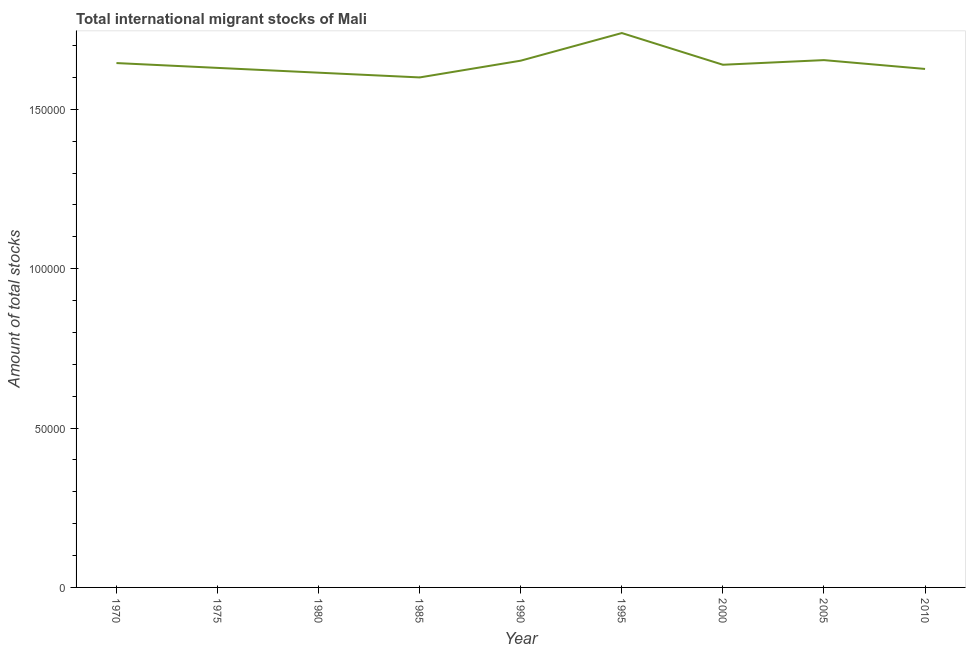What is the total number of international migrant stock in 1990?
Your answer should be very brief. 1.65e+05. Across all years, what is the maximum total number of international migrant stock?
Offer a very short reply. 1.74e+05. Across all years, what is the minimum total number of international migrant stock?
Your answer should be compact. 1.60e+05. In which year was the total number of international migrant stock minimum?
Give a very brief answer. 1985. What is the sum of the total number of international migrant stock?
Provide a succinct answer. 1.48e+06. What is the difference between the total number of international migrant stock in 1970 and 2005?
Make the answer very short. -925. What is the average total number of international migrant stock per year?
Your answer should be compact. 1.64e+05. What is the median total number of international migrant stock?
Your response must be concise. 1.64e+05. Do a majority of the years between 1995 and 1980 (inclusive) have total number of international migrant stock greater than 80000 ?
Provide a short and direct response. Yes. What is the ratio of the total number of international migrant stock in 1985 to that in 2000?
Make the answer very short. 0.98. Is the total number of international migrant stock in 1990 less than that in 2010?
Your response must be concise. No. Is the difference between the total number of international migrant stock in 1970 and 2005 greater than the difference between any two years?
Give a very brief answer. No. What is the difference between the highest and the second highest total number of international migrant stock?
Offer a terse response. 8494. Is the sum of the total number of international migrant stock in 1975 and 2000 greater than the maximum total number of international migrant stock across all years?
Ensure brevity in your answer.  Yes. What is the difference between the highest and the lowest total number of international migrant stock?
Your response must be concise. 1.39e+04. In how many years, is the total number of international migrant stock greater than the average total number of international migrant stock taken over all years?
Your response must be concise. 4. Does the total number of international migrant stock monotonically increase over the years?
Provide a succinct answer. No. How many years are there in the graph?
Give a very brief answer. 9. What is the difference between two consecutive major ticks on the Y-axis?
Keep it short and to the point. 5.00e+04. What is the title of the graph?
Your answer should be very brief. Total international migrant stocks of Mali. What is the label or title of the Y-axis?
Provide a short and direct response. Amount of total stocks. What is the Amount of total stocks in 1970?
Offer a very short reply. 1.65e+05. What is the Amount of total stocks of 1975?
Your response must be concise. 1.63e+05. What is the Amount of total stocks in 1980?
Keep it short and to the point. 1.62e+05. What is the Amount of total stocks in 1985?
Provide a succinct answer. 1.60e+05. What is the Amount of total stocks of 1990?
Your answer should be very brief. 1.65e+05. What is the Amount of total stocks of 1995?
Provide a short and direct response. 1.74e+05. What is the Amount of total stocks in 2000?
Your response must be concise. 1.64e+05. What is the Amount of total stocks in 2005?
Make the answer very short. 1.65e+05. What is the Amount of total stocks of 2010?
Provide a short and direct response. 1.63e+05. What is the difference between the Amount of total stocks in 1970 and 1975?
Your response must be concise. 1515. What is the difference between the Amount of total stocks in 1970 and 1980?
Ensure brevity in your answer.  3017. What is the difference between the Amount of total stocks in 1970 and 1985?
Keep it short and to the point. 4504. What is the difference between the Amount of total stocks in 1970 and 1990?
Offer a very short reply. -752. What is the difference between the Amount of total stocks in 1970 and 1995?
Your answer should be very brief. -9419. What is the difference between the Amount of total stocks in 1970 and 2000?
Give a very brief answer. 529. What is the difference between the Amount of total stocks in 1970 and 2005?
Your answer should be very brief. -925. What is the difference between the Amount of total stocks in 1970 and 2010?
Ensure brevity in your answer.  1846. What is the difference between the Amount of total stocks in 1975 and 1980?
Your response must be concise. 1502. What is the difference between the Amount of total stocks in 1975 and 1985?
Your answer should be compact. 2989. What is the difference between the Amount of total stocks in 1975 and 1990?
Offer a terse response. -2267. What is the difference between the Amount of total stocks in 1975 and 1995?
Keep it short and to the point. -1.09e+04. What is the difference between the Amount of total stocks in 1975 and 2000?
Ensure brevity in your answer.  -986. What is the difference between the Amount of total stocks in 1975 and 2005?
Your answer should be very brief. -2440. What is the difference between the Amount of total stocks in 1975 and 2010?
Offer a terse response. 331. What is the difference between the Amount of total stocks in 1980 and 1985?
Your response must be concise. 1487. What is the difference between the Amount of total stocks in 1980 and 1990?
Offer a terse response. -3769. What is the difference between the Amount of total stocks in 1980 and 1995?
Your answer should be very brief. -1.24e+04. What is the difference between the Amount of total stocks in 1980 and 2000?
Make the answer very short. -2488. What is the difference between the Amount of total stocks in 1980 and 2005?
Give a very brief answer. -3942. What is the difference between the Amount of total stocks in 1980 and 2010?
Make the answer very short. -1171. What is the difference between the Amount of total stocks in 1985 and 1990?
Your answer should be compact. -5256. What is the difference between the Amount of total stocks in 1985 and 1995?
Your response must be concise. -1.39e+04. What is the difference between the Amount of total stocks in 1985 and 2000?
Your answer should be compact. -3975. What is the difference between the Amount of total stocks in 1985 and 2005?
Provide a short and direct response. -5429. What is the difference between the Amount of total stocks in 1985 and 2010?
Your answer should be very brief. -2658. What is the difference between the Amount of total stocks in 1990 and 1995?
Your answer should be very brief. -8667. What is the difference between the Amount of total stocks in 1990 and 2000?
Keep it short and to the point. 1281. What is the difference between the Amount of total stocks in 1990 and 2005?
Your answer should be very brief. -173. What is the difference between the Amount of total stocks in 1990 and 2010?
Keep it short and to the point. 2598. What is the difference between the Amount of total stocks in 1995 and 2000?
Your answer should be compact. 9948. What is the difference between the Amount of total stocks in 1995 and 2005?
Offer a very short reply. 8494. What is the difference between the Amount of total stocks in 1995 and 2010?
Provide a succinct answer. 1.13e+04. What is the difference between the Amount of total stocks in 2000 and 2005?
Provide a succinct answer. -1454. What is the difference between the Amount of total stocks in 2000 and 2010?
Your answer should be compact. 1317. What is the difference between the Amount of total stocks in 2005 and 2010?
Offer a terse response. 2771. What is the ratio of the Amount of total stocks in 1970 to that in 1975?
Ensure brevity in your answer.  1.01. What is the ratio of the Amount of total stocks in 1970 to that in 1980?
Give a very brief answer. 1.02. What is the ratio of the Amount of total stocks in 1970 to that in 1985?
Your response must be concise. 1.03. What is the ratio of the Amount of total stocks in 1970 to that in 1995?
Your response must be concise. 0.95. What is the ratio of the Amount of total stocks in 1970 to that in 2000?
Ensure brevity in your answer.  1. What is the ratio of the Amount of total stocks in 1970 to that in 2010?
Give a very brief answer. 1.01. What is the ratio of the Amount of total stocks in 1975 to that in 1980?
Ensure brevity in your answer.  1.01. What is the ratio of the Amount of total stocks in 1975 to that in 1995?
Provide a succinct answer. 0.94. What is the ratio of the Amount of total stocks in 1980 to that in 1985?
Give a very brief answer. 1.01. What is the ratio of the Amount of total stocks in 1980 to that in 1990?
Your answer should be compact. 0.98. What is the ratio of the Amount of total stocks in 1980 to that in 1995?
Give a very brief answer. 0.93. What is the ratio of the Amount of total stocks in 1980 to that in 2000?
Provide a short and direct response. 0.98. What is the ratio of the Amount of total stocks in 1980 to that in 2010?
Make the answer very short. 0.99. What is the ratio of the Amount of total stocks in 1985 to that in 1990?
Your response must be concise. 0.97. What is the ratio of the Amount of total stocks in 1985 to that in 2000?
Offer a terse response. 0.98. What is the ratio of the Amount of total stocks in 1985 to that in 2010?
Make the answer very short. 0.98. What is the ratio of the Amount of total stocks in 1990 to that in 1995?
Give a very brief answer. 0.95. What is the ratio of the Amount of total stocks in 1990 to that in 2000?
Offer a very short reply. 1.01. What is the ratio of the Amount of total stocks in 1990 to that in 2005?
Provide a short and direct response. 1. What is the ratio of the Amount of total stocks in 1995 to that in 2000?
Your answer should be very brief. 1.06. What is the ratio of the Amount of total stocks in 1995 to that in 2005?
Make the answer very short. 1.05. What is the ratio of the Amount of total stocks in 1995 to that in 2010?
Offer a terse response. 1.07. What is the ratio of the Amount of total stocks in 2005 to that in 2010?
Keep it short and to the point. 1.02. 